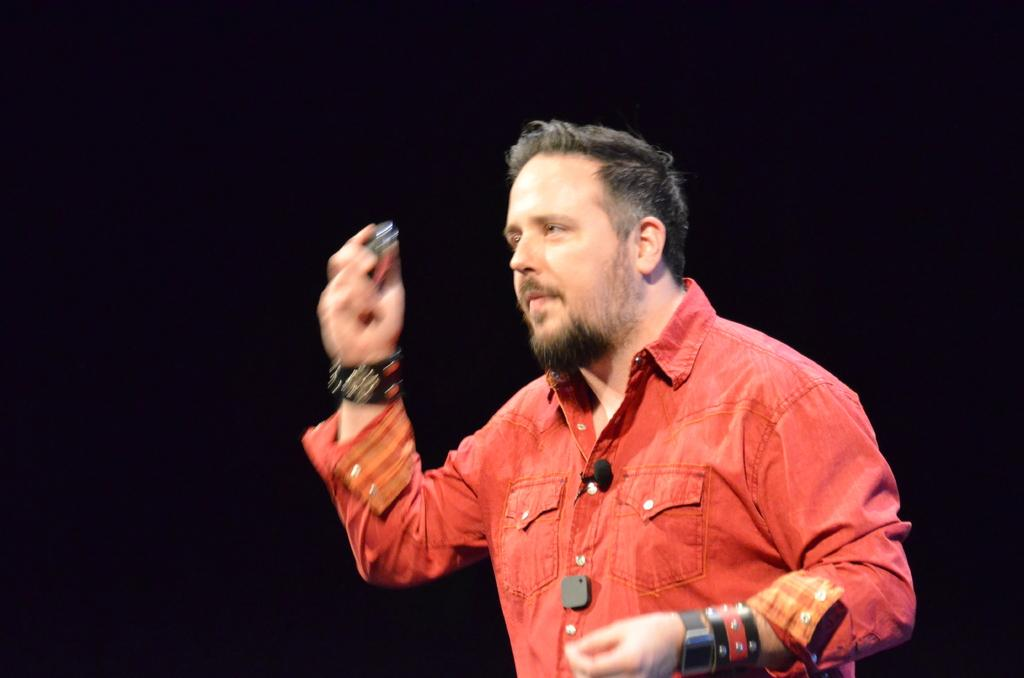What is the main subject of the image? There is a person in the image. What is the person wearing? The person is wearing a red dress. What is the person holding in the image? The person is holding something. What can be seen in the background of the image? The background of the image is black. What type of pain can be seen on the person's face in the image? There is no indication of pain on the person's face in the image. What kind of mark is visible on the person's dress in the image? There is no mark visible on the person's dress in the image. 